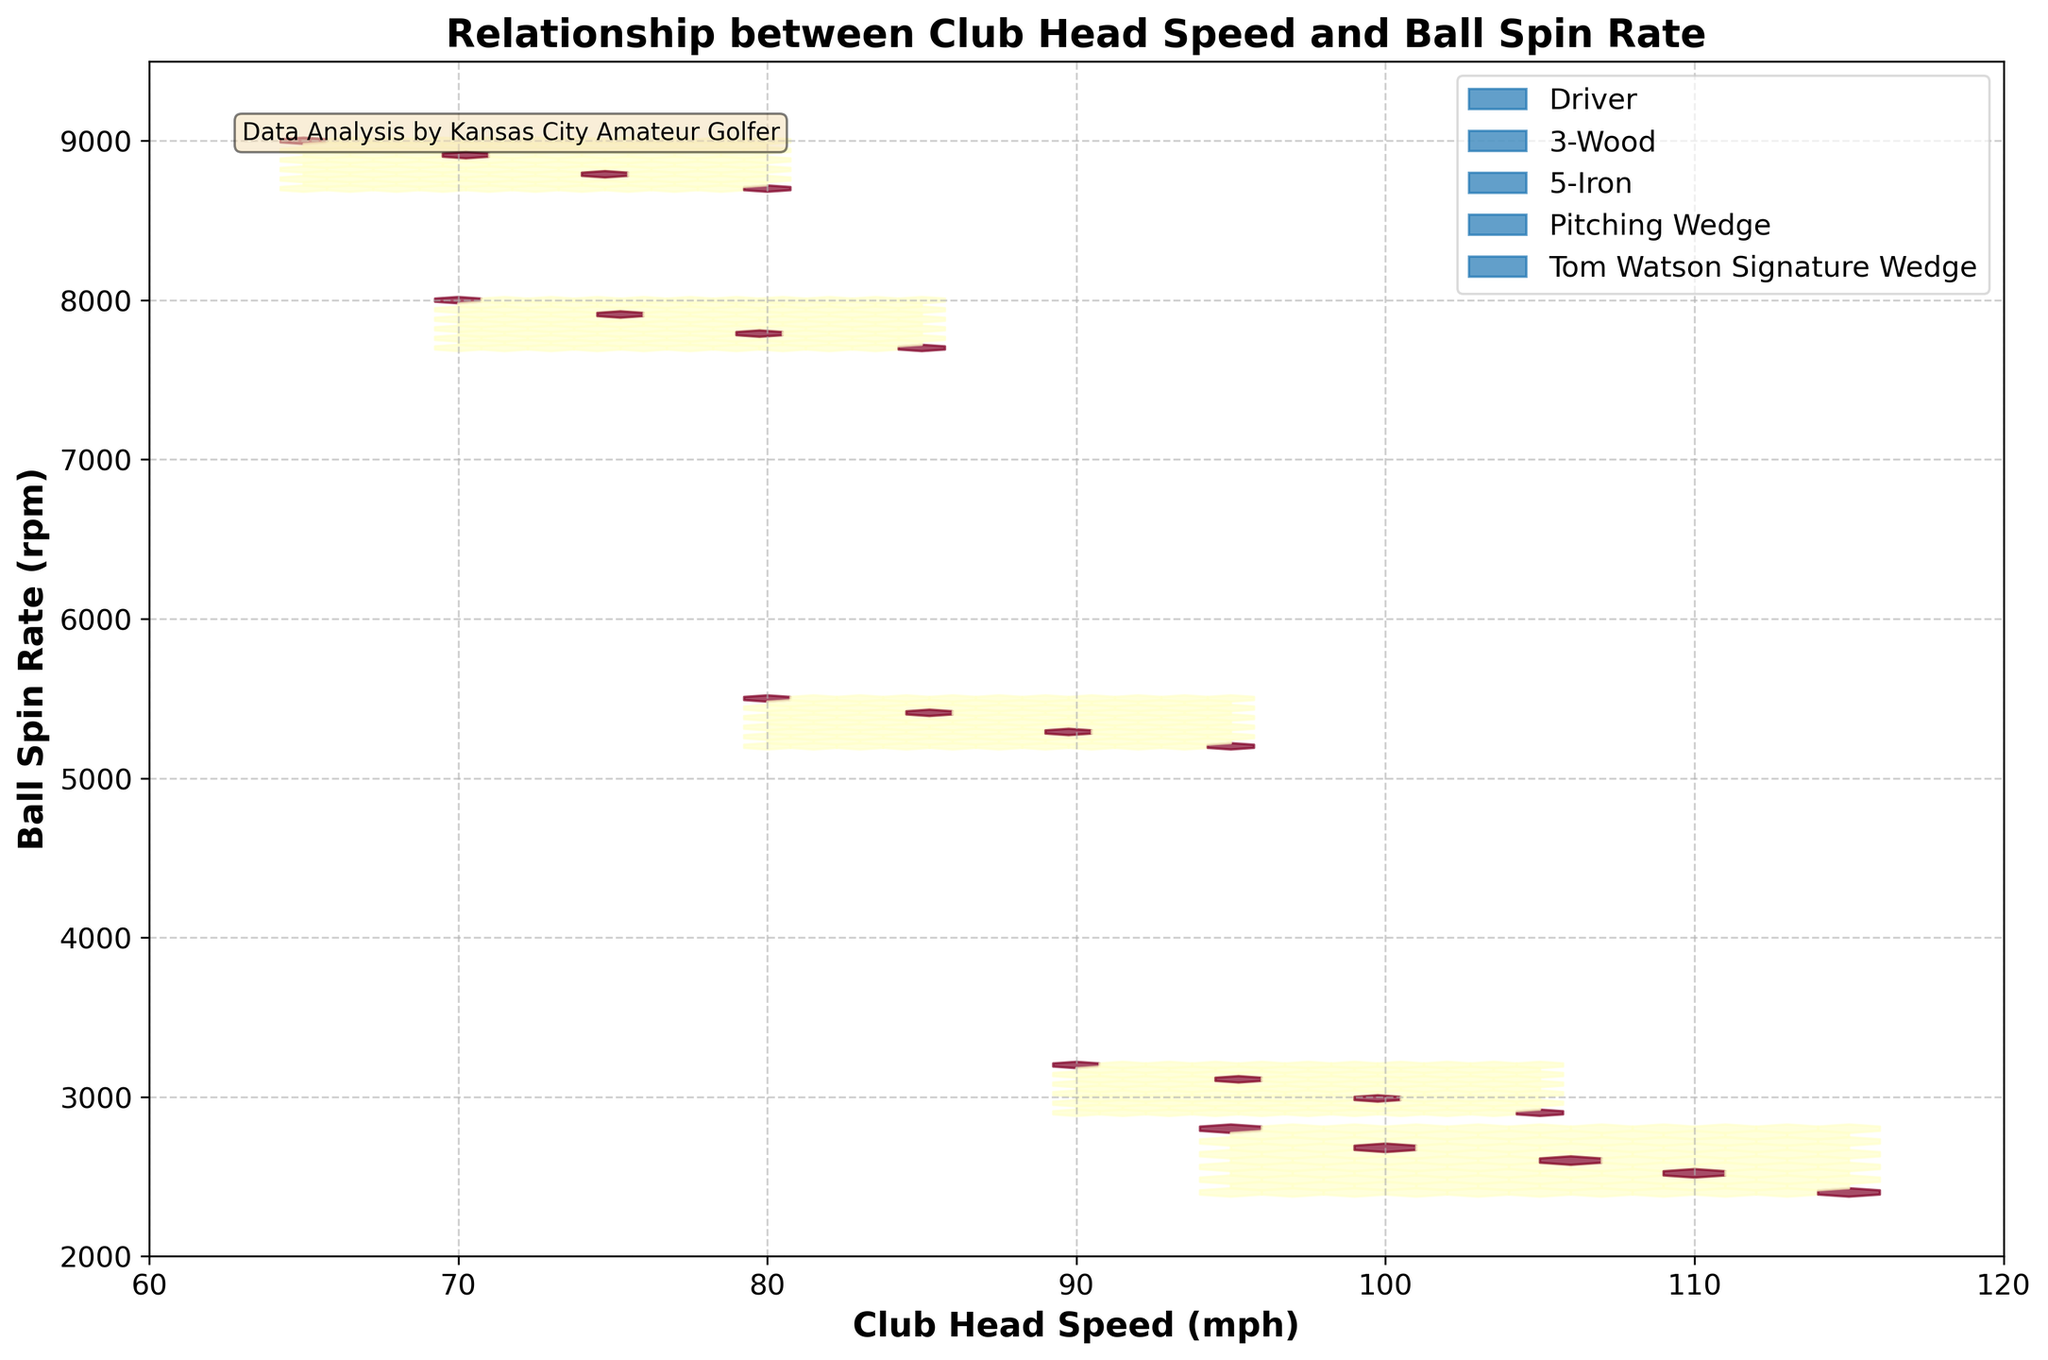What's the title of the figure? The title of the figure is usually placed at the top of the plot. Here, it's stated in a bold font.
Answer: Relationship between Club Head Speed and Ball Spin Rate What are the x-axis and y-axis labels? The labels for the axes are usually positioned near them. The x-axis label is at the bottom of the plot and the y-axis label is on the left side.
Answer: Club Head Speed (mph) and Ball Spin Rate (rpm) Which club has the highest ball spin rate for the given data? Observing the plot, the highest ball spin rates are at the uppermost points, which are color-coded. By the legend, the "Tom Watson Signature Wedge" has the highest spin rate.
Answer: Tom Watson Signature Wedge What does the text annotation at the top-left corner of the plot say? The text annotation is positioned at the top-left corner within a wheat-colored box.
Answer: Data Analysis by Kansas City Amateur Golfer Which club type has the densest hexbin near the highest head speeds? The densest hexbin region is the area with the highest concentration of points. Observing the regions near the highest head speeds, the "Driver" with its color stands out.
Answer: Driver How does the spin rate change with head speed for the '3-Wood'? To answer this, look at the hexbins and how the spin rate values plotted for "3-Wood" change as the head speed increases. The trend shows that spin rate decreases as head speed increases for the "3-Wood".
Answer: Spin rate decreases as head speed increases Compare the head speed and spin rate for '5-Iron' and 'Pitching Wedge'. Which has a higher average spin rate? Calculate the spin rates for '5-Iron' which are around 5300-5500 rpm and 'Pitching Wedge' which are around 7700-8000 rpm. By comparing the mid-ranges, the 'Pitching Wedge' has a higher average spin rate.
Answer: Pitching Wedge How many different types of clubs are displayed in the plot? Check the legend or count the number of different colors used in the plot. Each color represents a different type of club.
Answer: 5 What ranges of head speed and spin rate are covered in the plot? By looking at the x-axis and y-axis limits, observe the minimum and maximum values. The x-axis ranges from 60 to 120 mph and the y-axis ranges from 2000 to 9500 rpm.
Answer: 60 to 120 mph (head speed) and 2000 to 9500 rpm (spin rate) 